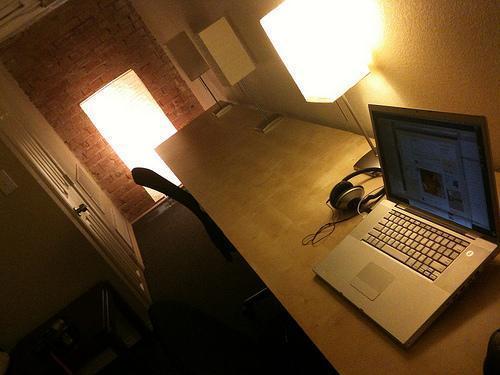How many laptops are there?
Give a very brief answer. 1. How many lamps are on?
Give a very brief answer. 1. 